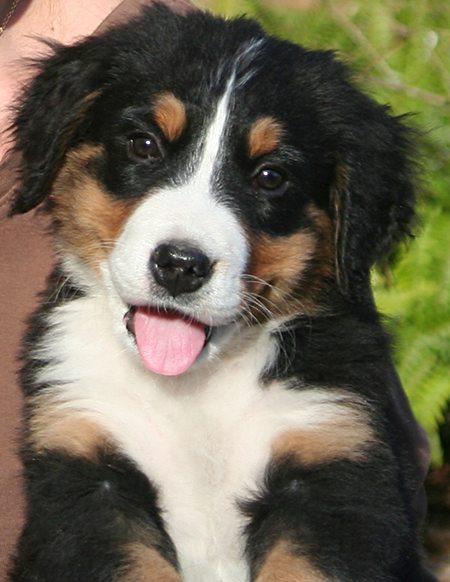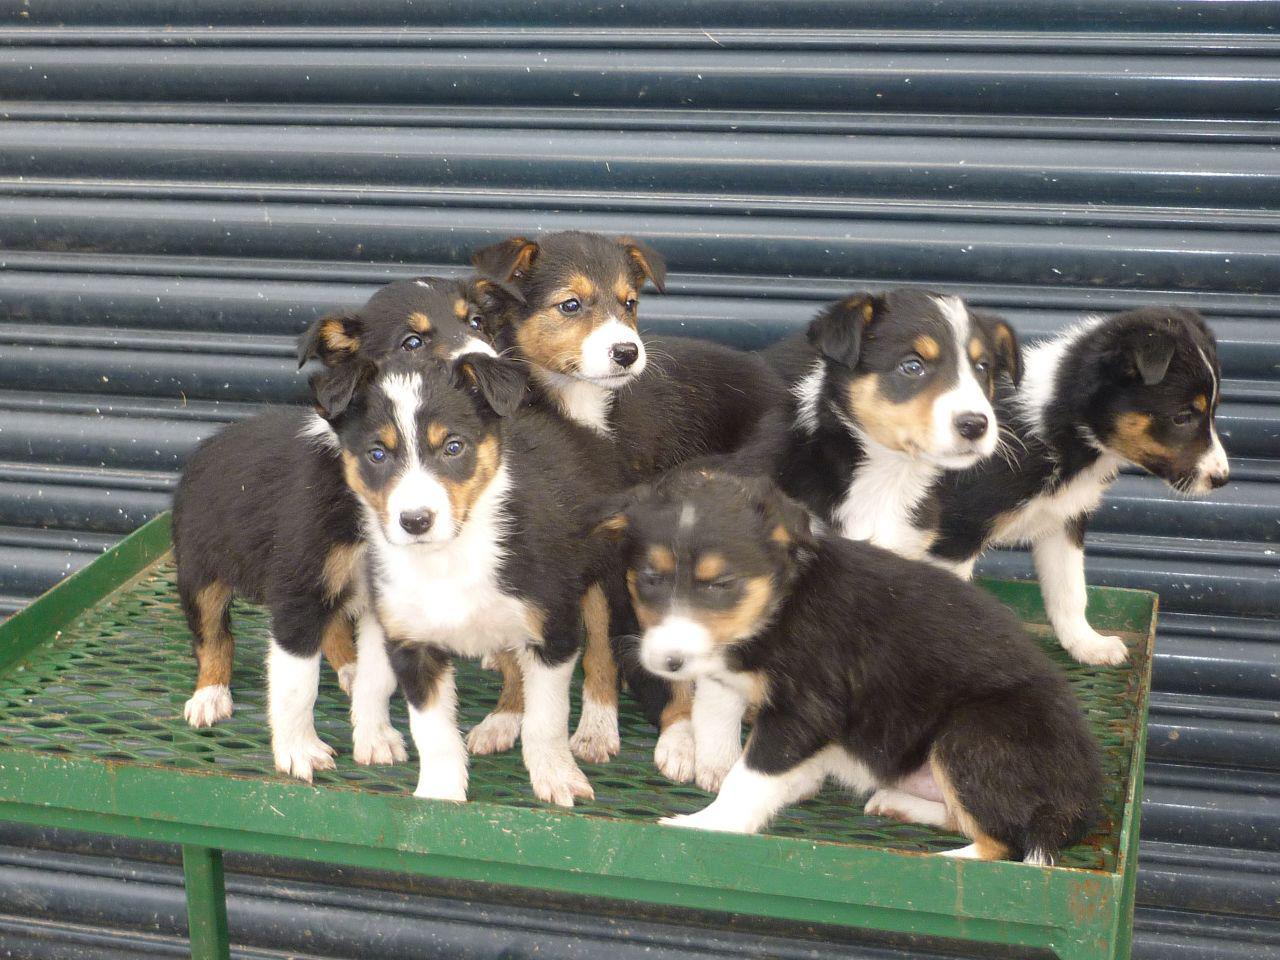The first image is the image on the left, the second image is the image on the right. Evaluate the accuracy of this statement regarding the images: "The right image contains exactly two dogs.". Is it true? Answer yes or no. No. The first image is the image on the left, the second image is the image on the right. Assess this claim about the two images: "Each image features exactly two animals posed close together, and one image shows two dogs in a reclining position with front paws extended.". Correct or not? Answer yes or no. No. 